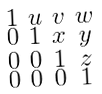<formula> <loc_0><loc_0><loc_500><loc_500>\begin{smallmatrix} 1 & u & v & w \\ 0 & 1 & x & y \\ 0 & 0 & 1 & z \\ 0 & 0 & 0 & 1 \end{smallmatrix}</formula> 